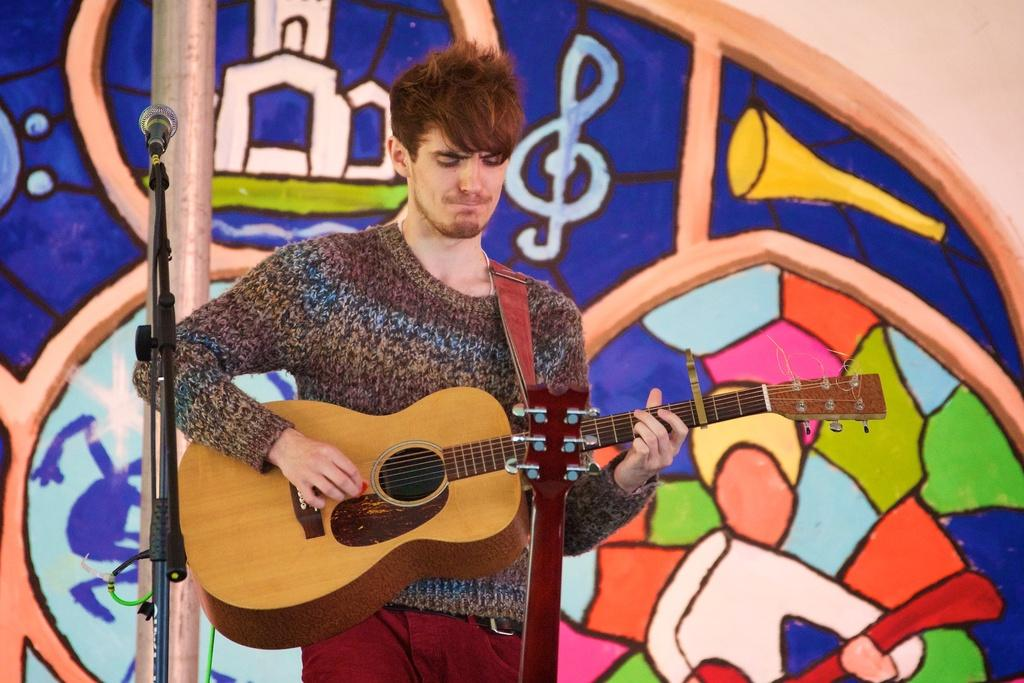What is the human in the image doing? The human is playing a guitar. What object is present in the image that is typically used for amplifying sound? There is a microphone in the image. What is the purpose of the stand in the image? The stand is likely used to hold the guitar or other equipment. What can be seen in the image that connects various objects together? There are wires ines in the image. What can be seen in the background of the image? There is a colorful wall in the background of the image. How many fangs can be seen on the guitar in the image? There are no fangs present on the guitar or any other object in the image. 